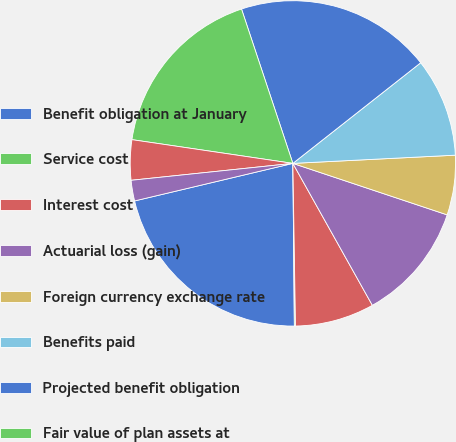<chart> <loc_0><loc_0><loc_500><loc_500><pie_chart><fcel>Benefit obligation at January<fcel>Service cost<fcel>Interest cost<fcel>Actuarial loss (gain)<fcel>Foreign currency exchange rate<fcel>Benefits paid<fcel>Projected benefit obligation<fcel>Fair value of plan assets at<fcel>Actual return on plan assets<fcel>Employer contributions<nl><fcel>21.44%<fcel>0.11%<fcel>7.87%<fcel>11.75%<fcel>5.93%<fcel>9.81%<fcel>19.5%<fcel>17.56%<fcel>3.99%<fcel>2.05%<nl></chart> 